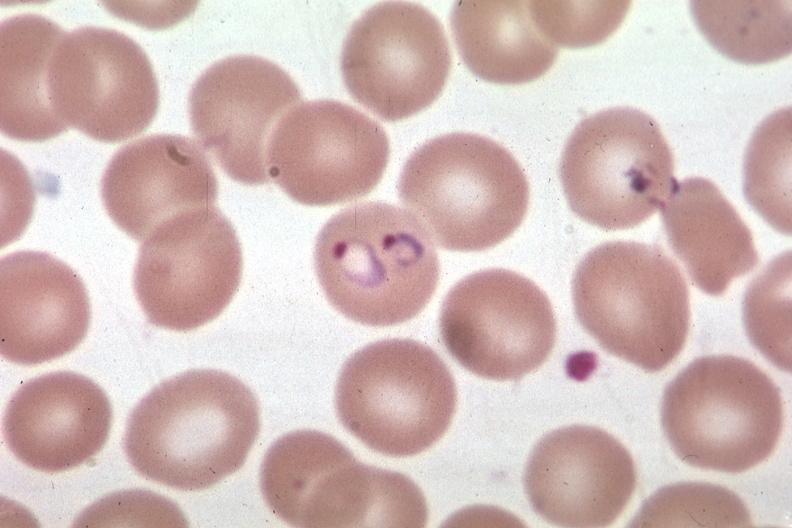what does this image show?
Answer the question using a single word or phrase. Oil wrights excellent 